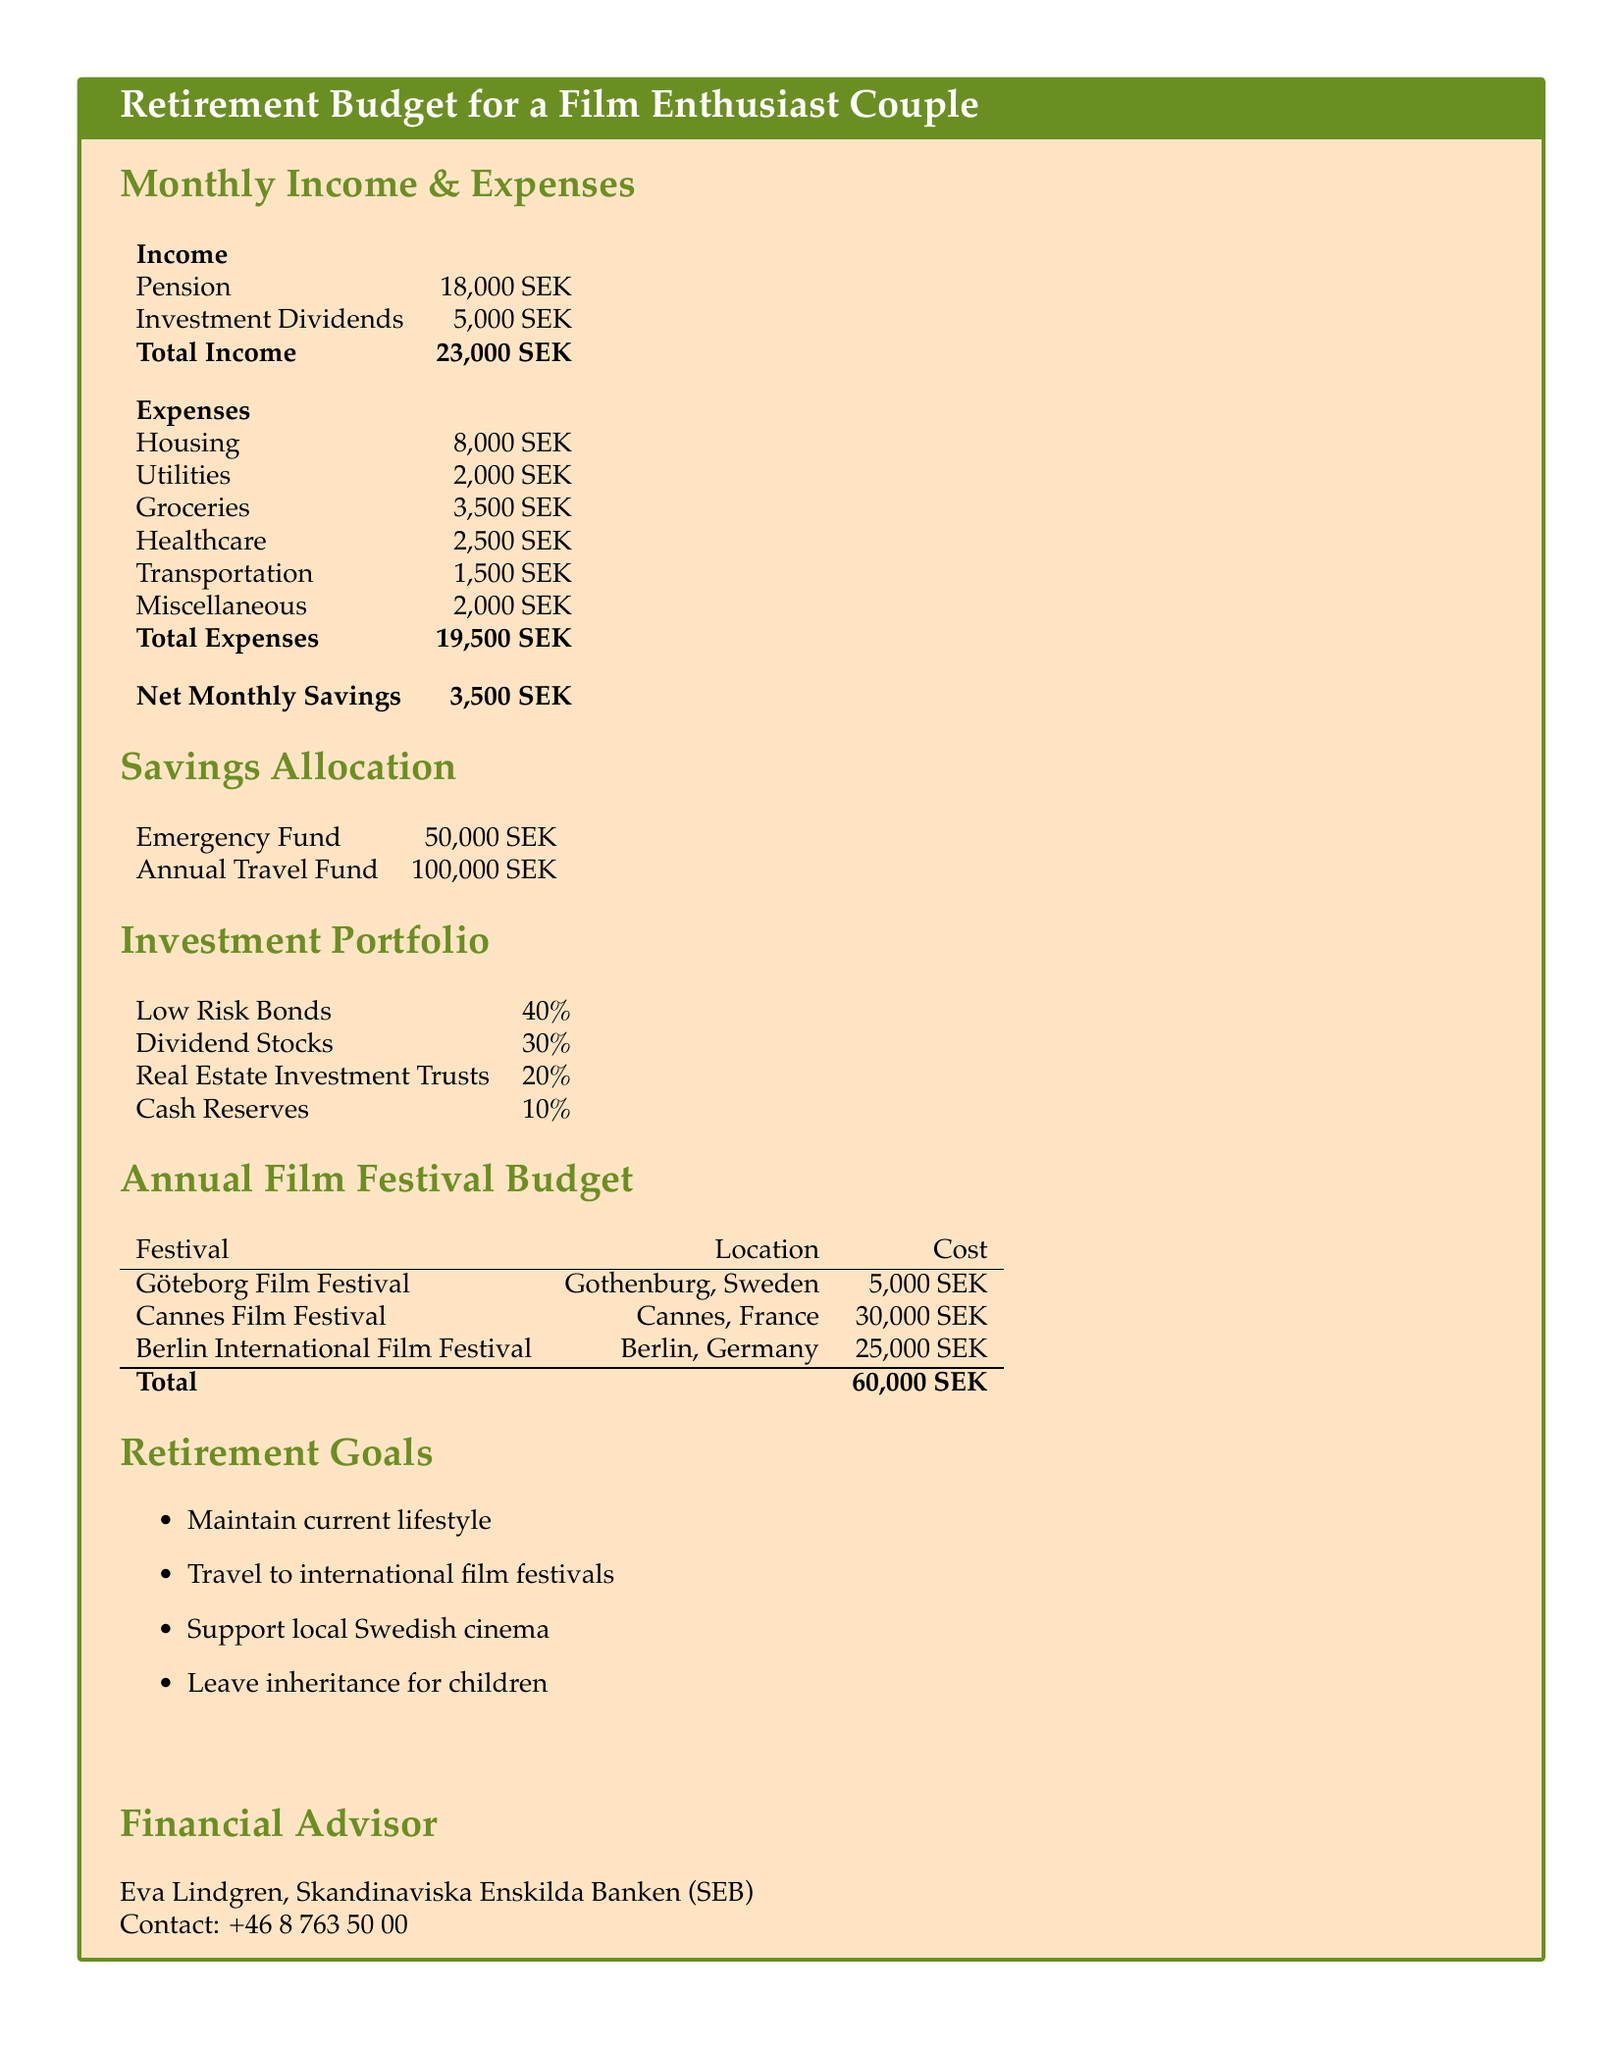What is the total monthly income? The total monthly income is calculated by adding pension and investment dividends, which are 18,000 SEK + 5,000 SEK = 23,000 SEK.
Answer: 23,000 SEK What is the total monthly expenses? The total monthly expenses are calculated by adding all expense categories: housing, utilities, groceries, healthcare, transportation, and miscellaneous, totaling 8,000 SEK + 2,000 SEK + 3,500 SEK + 2,500 SEK + 1,500 SEK + 2,000 SEK = 19,500 SEK.
Answer: 19,500 SEK What is the net monthly savings? Net monthly savings are calculated by subtracting total expenses from total income, 23,000 SEK - 19,500 SEK = 3,500 SEK.
Answer: 3,500 SEK What is allocated for the annual travel fund? The document specifies that 100,000 SEK is allocated for the annual travel fund.
Answer: 100,000 SEK How much does the Cannes Film Festival cost? The document states that attending the Cannes Film Festival costs 30,000 SEK.
Answer: 30,000 SEK What is the primary retirement goal? One of the primary retirement goals mentioned in the document is to travel to international film festivals.
Answer: Travel to international film festivals What percentage of the investment portfolio is in low-risk bonds? The investment portfolio allocates 40% to low-risk bonds.
Answer: 40% Who is the financial advisor? The document lists Eva Lindgren as the financial advisor.
Answer: Eva Lindgren What is the total cost for the film festivals listed? The total cost for the listed film festivals is specified as 60,000 SEK in the document.
Answer: 60,000 SEK 